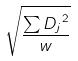<formula> <loc_0><loc_0><loc_500><loc_500>\sqrt { \frac { \sum { D _ { j } } ^ { 2 } } { w } }</formula> 